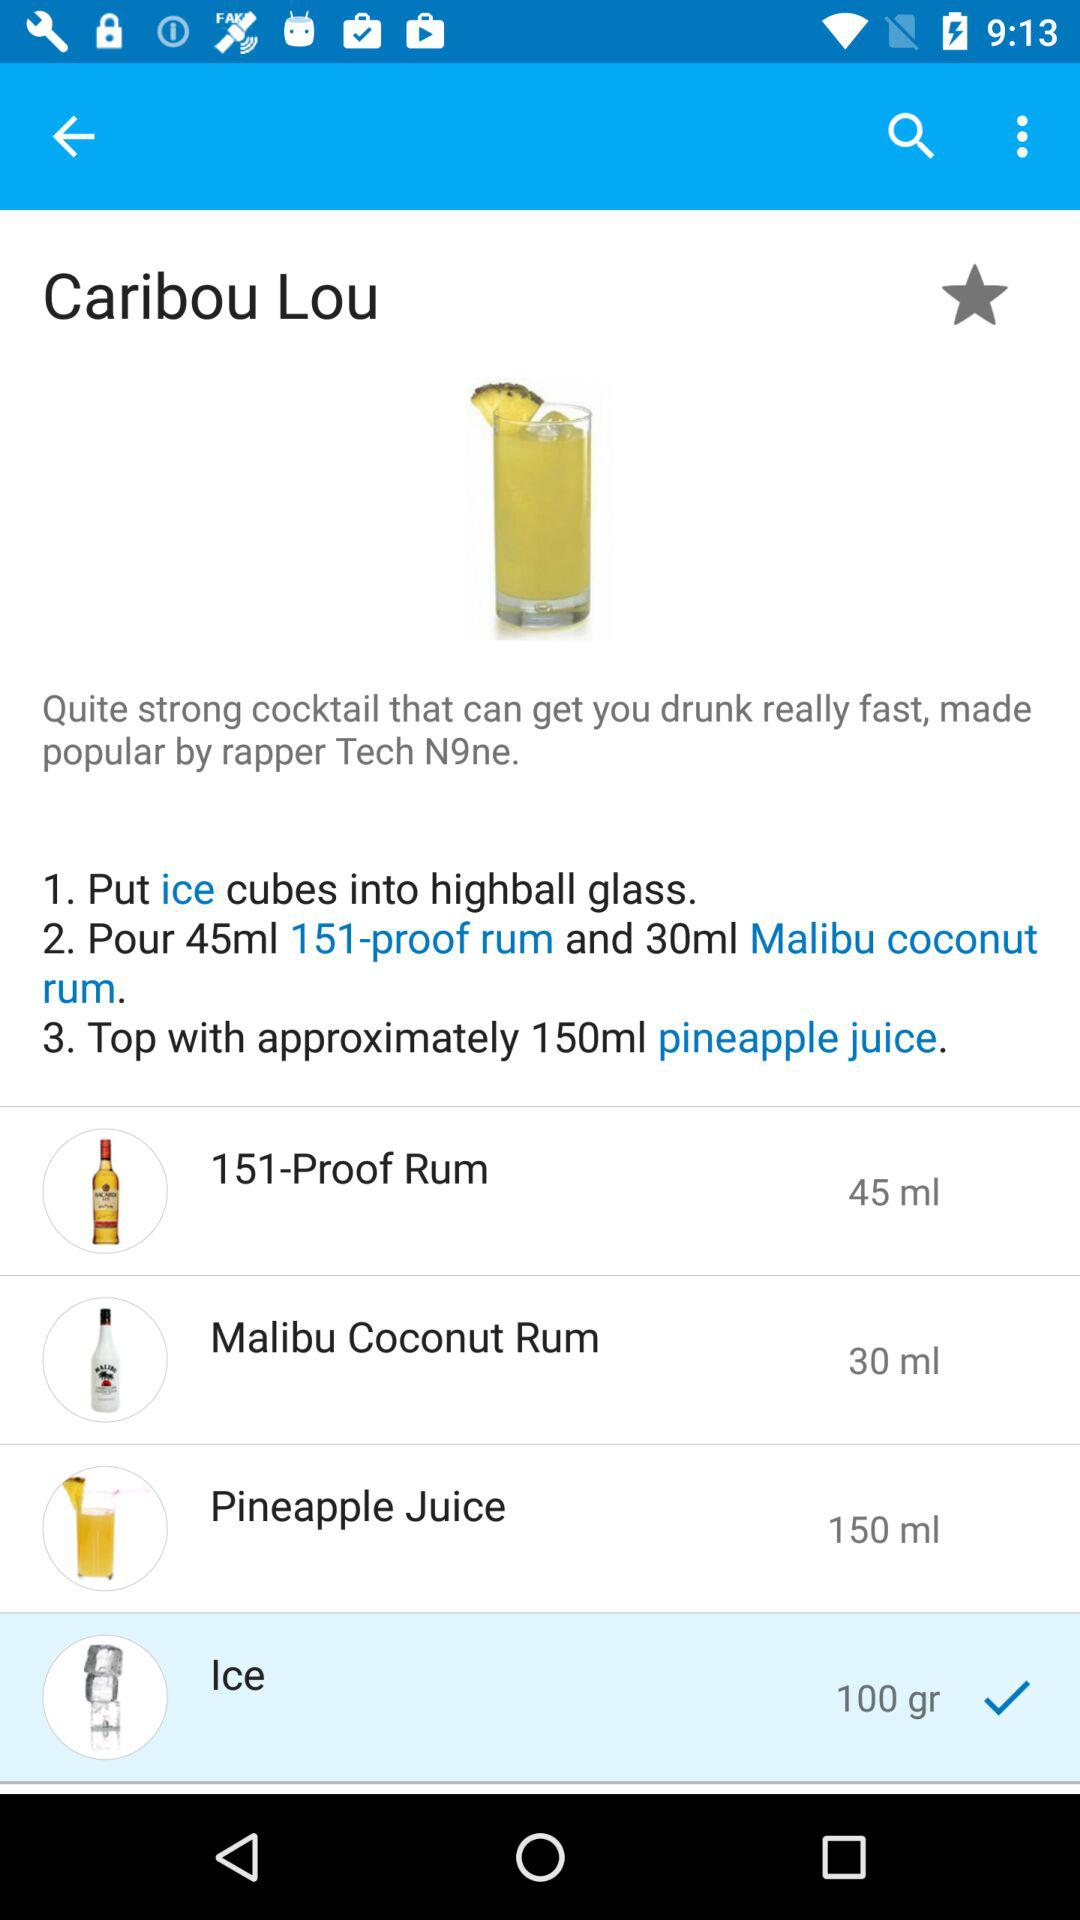What is the selected option? The selected option is "Ice". 